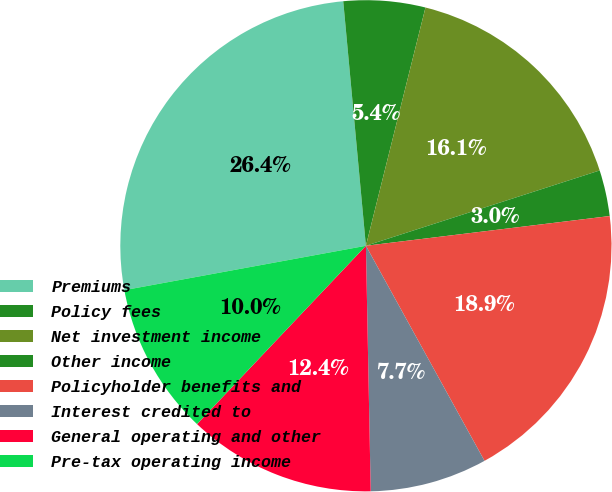Convert chart. <chart><loc_0><loc_0><loc_500><loc_500><pie_chart><fcel>Premiums<fcel>Policy fees<fcel>Net investment income<fcel>Other income<fcel>Policyholder benefits and<fcel>Interest credited to<fcel>General operating and other<fcel>Pre-tax operating income<nl><fcel>26.42%<fcel>5.37%<fcel>16.14%<fcel>3.03%<fcel>18.91%<fcel>7.71%<fcel>12.38%<fcel>10.04%<nl></chart> 